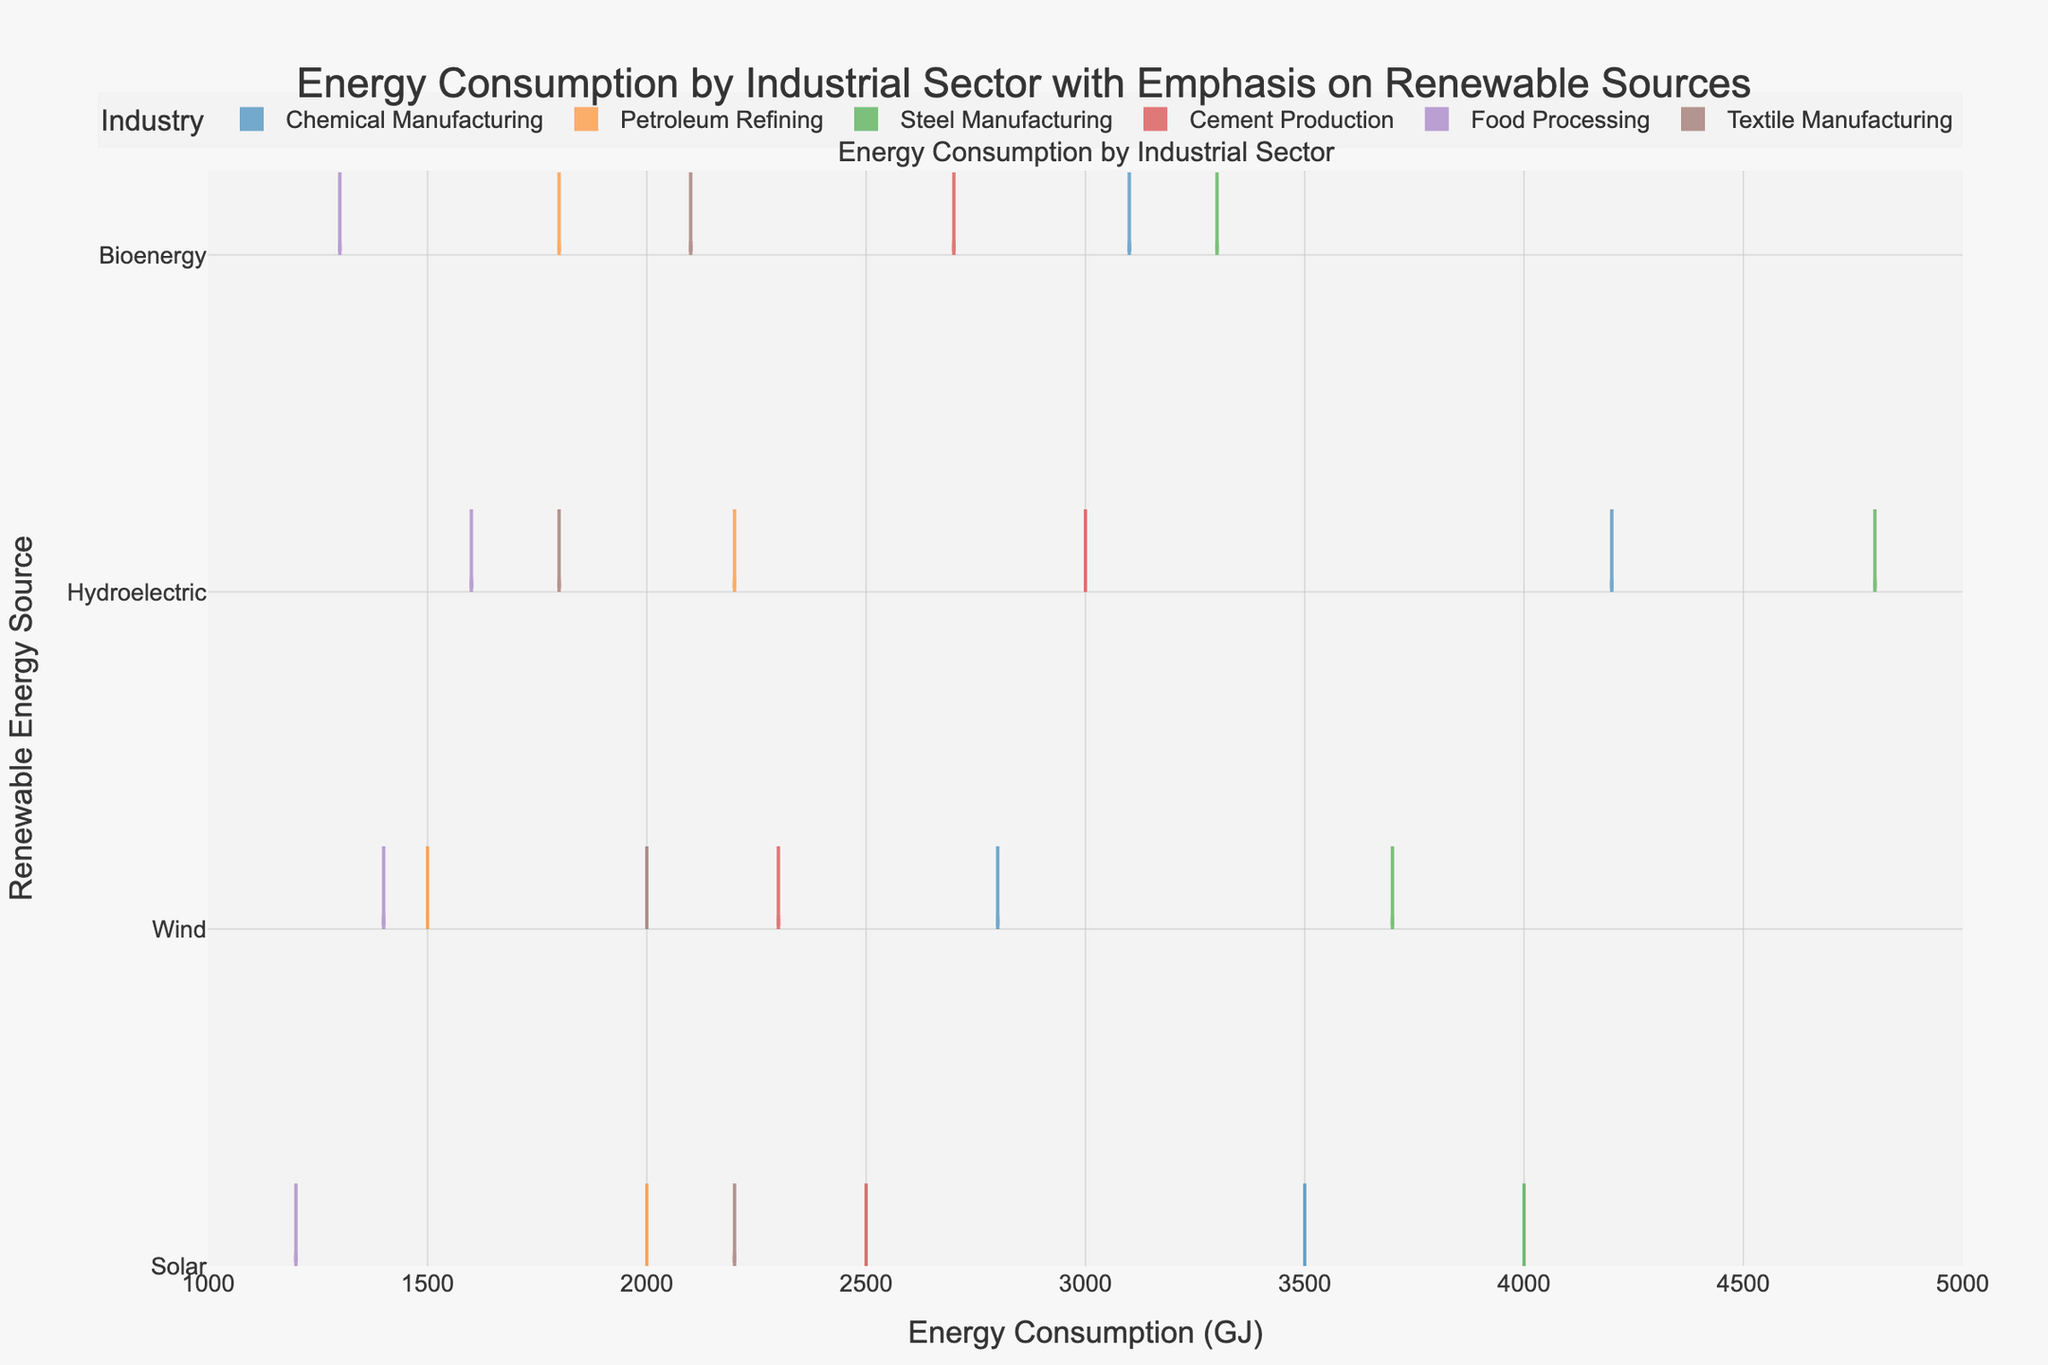What is the title of the figure? The title is usually placed at the top of the figure. In this case, it states "Energy Consumption by Industrial Sector with Emphasis on Renewable Sources".
Answer: Energy Consumption by Industrial Sector with Emphasis on Renewable Sources What are the renewable energy sources listed on the y-axis? By examining the y-axis of the figure, we can identify four renewable energy sources: Solar, Wind, Hydroelectric, and Bioenergy.
Answer: Solar, Wind, Hydroelectric, Bioenergy Which industry shows the highest energy consumption for Hydroelectric energy? Comparing the heights of the violin plots for Hydroelectric energy across different industries, Steel Manufacturing has the highest energy consumption value.
Answer: Steel Manufacturing Which industry has the lowest range of energy consumption for Bioenergy? The range is indicated by the spread of the violin plots. The Food Processing industry has the smallest spread, indicating the lowest range of energy consumption for Bioenergy.
Answer: Food Processing What is the range of energy consumption values for Solar energy in Chemical Manufacturing? From the details of the Chemical Manufacturing violin plot for Solar energy, the range can be observed from the lowest to the highest data points, which is from 3500 GJ to 4000 GJ.
Answer: 3500 GJ to 4000 GJ How does the Solar energy consumption of Textile Manufacturing compare to Chemical Manufacturing? Comparing the mean lines of both industries' Solar energy violin plots, it can be seen that Textile Manufacturing has a lower mean value (2200 GJ) than Chemical Manufacturing (3500 GJ).
Answer: Lower Which renewable energy source has the most consistent energy consumption across all industries? Consistency can be assessed by looking at the width of the violin plots. The narrower the plots, the more consistent the values. Bioenergy appears to have the most consistent consumption, with less variation in plot widths.
Answer: Bioenergy What is the average energy consumption for Wind energy across all industries? By averaging the mean points of Wind energy from all industries: (2800 + 1500 + 3700 + 2300 + 1400 + 2000)/6 = 2286.67 GJ.
Answer: 2286.67 GJ Which industry uses the most renewable energy sources on average? By comparing the mean energy consumption for all renewable sources across different industries. Summing up for each and then dividing by the number of sources: 
(3500+2800+4200+3100)/4 = 3400 GJ (Chemical Manufacturing),
(2000+1500+2200+1800)/4 = 1875 GJ (Petroleum Refining),
(4000+3700+4800+3300)/4 = 3950 GJ (Steel Manufacturing),
(2500+2300+3000+2700)/4 = 2625 GJ (Cement Production),
(1200+1400+1600+1300)/4 = 1375 GJ (Food Processing),
(2200+2000+1800+2100)/4 = 2025 GJ (Textile Manufacturing).
The highest average is 3950 GJ for Steel Manufacturing.
Answer: Steel Manufacturing 